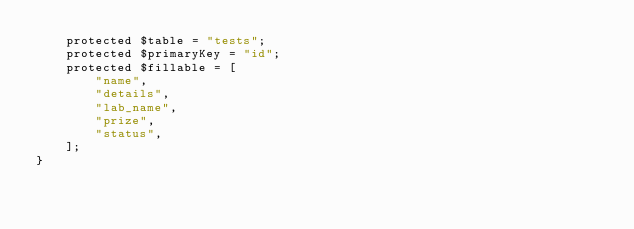<code> <loc_0><loc_0><loc_500><loc_500><_PHP_>    protected $table = "tests";
    protected $primaryKey = "id";
    protected $fillable = [
        "name",
        "details",
        "lab_name",
        "prize",
        "status",
    ];
}
</code> 